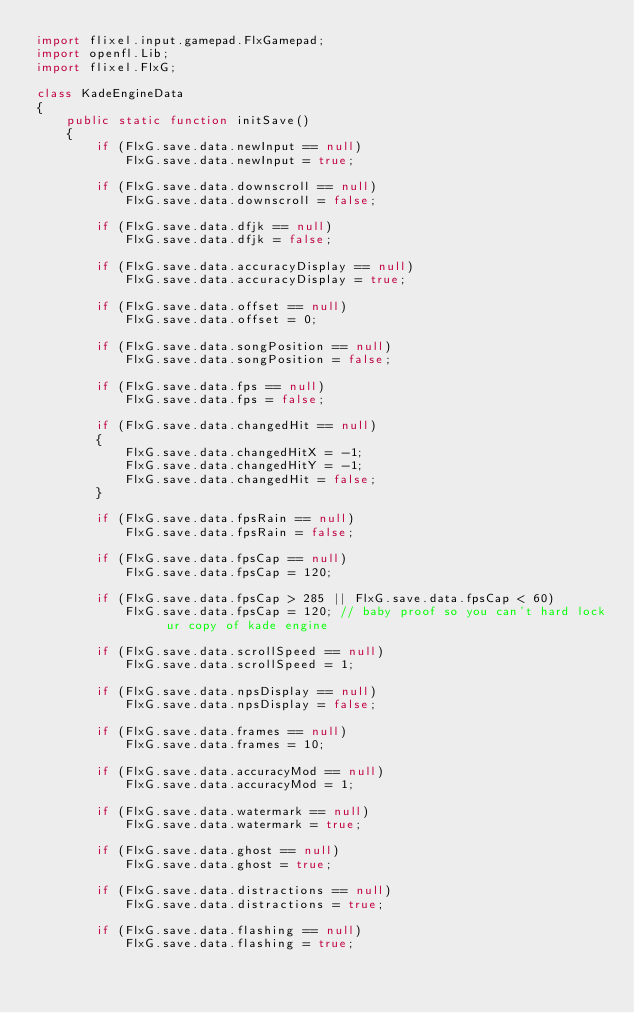Convert code to text. <code><loc_0><loc_0><loc_500><loc_500><_Haxe_>import flixel.input.gamepad.FlxGamepad;
import openfl.Lib;
import flixel.FlxG;

class KadeEngineData
{
    public static function initSave()
    {
        if (FlxG.save.data.newInput == null)
			FlxG.save.data.newInput = true;

		if (FlxG.save.data.downscroll == null)
			FlxG.save.data.downscroll = false;

		if (FlxG.save.data.dfjk == null)
			FlxG.save.data.dfjk = false;
			
		if (FlxG.save.data.accuracyDisplay == null)
			FlxG.save.data.accuracyDisplay = true;

		if (FlxG.save.data.offset == null)
			FlxG.save.data.offset = 0;

		if (FlxG.save.data.songPosition == null)
			FlxG.save.data.songPosition = false;

		if (FlxG.save.data.fps == null)
			FlxG.save.data.fps = false;

		if (FlxG.save.data.changedHit == null)
		{
			FlxG.save.data.changedHitX = -1;
			FlxG.save.data.changedHitY = -1;
			FlxG.save.data.changedHit = false;
		}

		if (FlxG.save.data.fpsRain == null)
			FlxG.save.data.fpsRain = false;

		if (FlxG.save.data.fpsCap == null)
			FlxG.save.data.fpsCap = 120;

		if (FlxG.save.data.fpsCap > 285 || FlxG.save.data.fpsCap < 60)
			FlxG.save.data.fpsCap = 120; // baby proof so you can't hard lock ur copy of kade engine
		
		if (FlxG.save.data.scrollSpeed == null)
			FlxG.save.data.scrollSpeed = 1;

		if (FlxG.save.data.npsDisplay == null)
			FlxG.save.data.npsDisplay = false;

		if (FlxG.save.data.frames == null)
			FlxG.save.data.frames = 10;

		if (FlxG.save.data.accuracyMod == null)
			FlxG.save.data.accuracyMod = 1;

		if (FlxG.save.data.watermark == null)
			FlxG.save.data.watermark = true;

		if (FlxG.save.data.ghost == null)
			FlxG.save.data.ghost = true;

		if (FlxG.save.data.distractions == null)
			FlxG.save.data.distractions = true;

		if (FlxG.save.data.flashing == null)
			FlxG.save.data.flashing = true;
</code> 